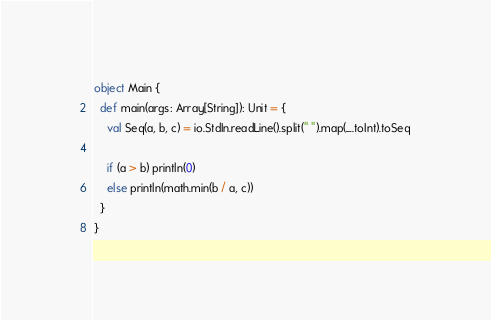<code> <loc_0><loc_0><loc_500><loc_500><_Scala_>object Main {
  def main(args: Array[String]): Unit = {
    val Seq(a, b, c) = io.StdIn.readLine().split(" ").map(_.toInt).toSeq

    if (a > b) println(0)
    else println(math.min(b / a, c))
  }
}</code> 